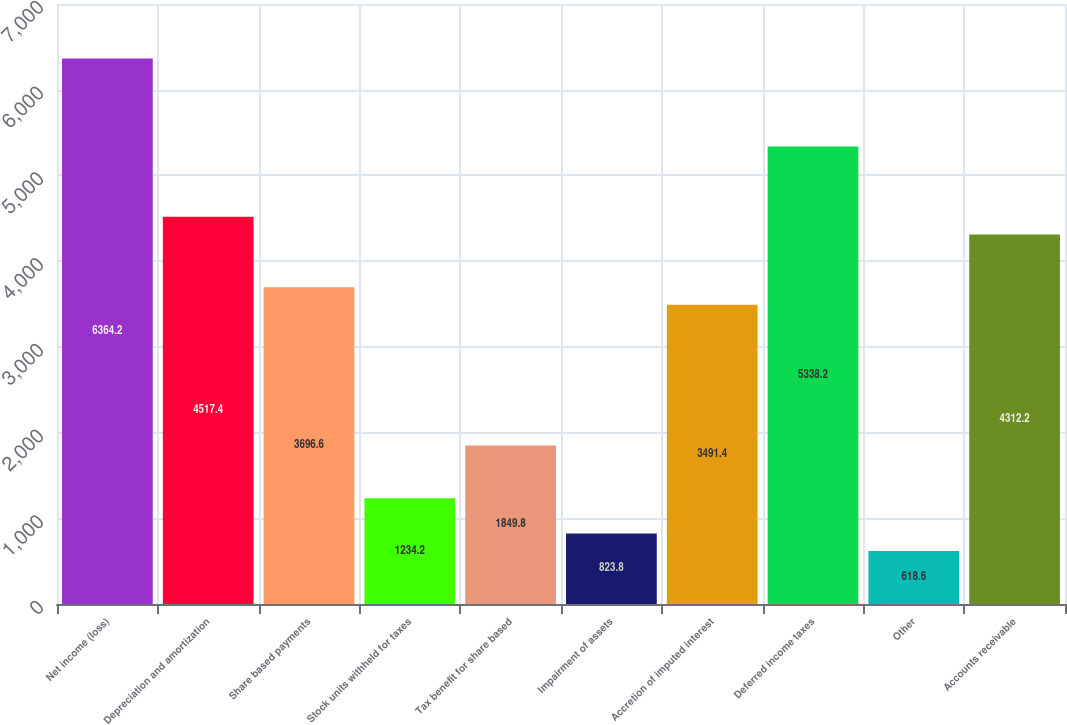<chart> <loc_0><loc_0><loc_500><loc_500><bar_chart><fcel>Net income (loss)<fcel>Depreciation and amortization<fcel>Share based payments<fcel>Stock units withheld for taxes<fcel>Tax benefit for share based<fcel>Impairment of assets<fcel>Accretion of imputed interest<fcel>Deferred income taxes<fcel>Other<fcel>Accounts receivable<nl><fcel>6364.2<fcel>4517.4<fcel>3696.6<fcel>1234.2<fcel>1849.8<fcel>823.8<fcel>3491.4<fcel>5338.2<fcel>618.6<fcel>4312.2<nl></chart> 